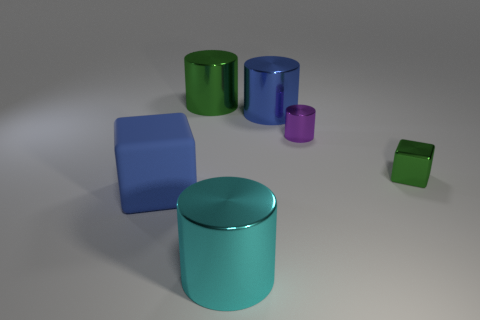Subtract all large blue cylinders. How many cylinders are left? 3 Subtract all purple cylinders. How many cylinders are left? 3 Subtract all blocks. How many objects are left? 4 Subtract all yellow cylinders. Subtract all green cubes. How many cylinders are left? 4 Subtract all brown cubes. How many gray cylinders are left? 0 Subtract all big blue things. Subtract all purple metallic cylinders. How many objects are left? 3 Add 1 cyan shiny cylinders. How many cyan shiny cylinders are left? 2 Add 3 small red rubber cylinders. How many small red rubber cylinders exist? 3 Add 4 small green things. How many objects exist? 10 Subtract 1 blue blocks. How many objects are left? 5 